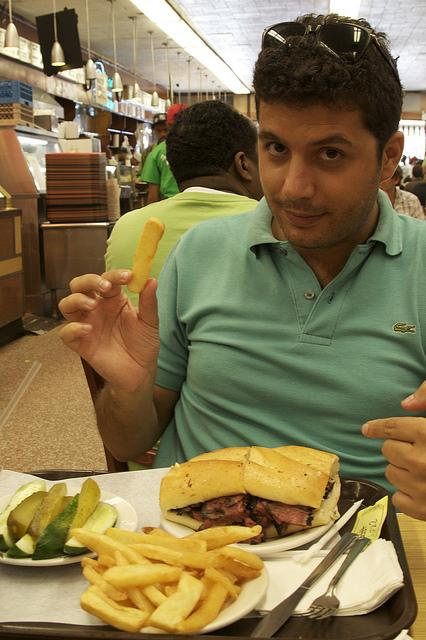The type of restaurant the man is eating at is more likely a what?

Choices:
A) chinese
B) mexican food
C) steakhouse
D) italian cuisine steakhouse 